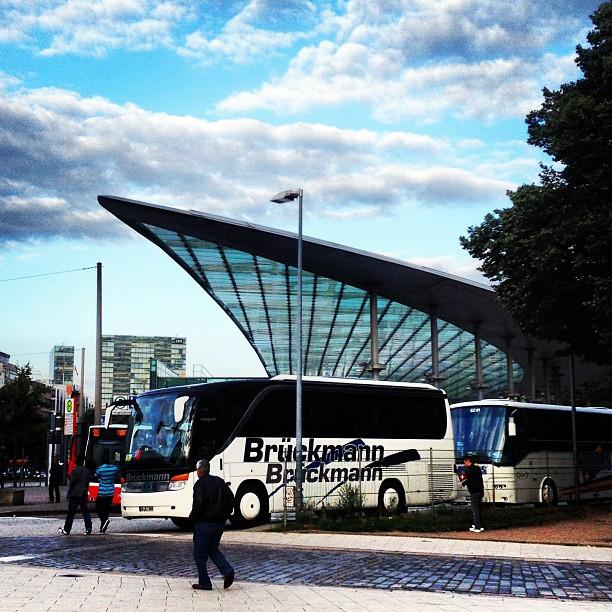What style of architecture is the triangular glass building in the background?
Quick response, please. Modern. What type of vehicles are these?
Write a very short answer. Buses. Is this a German tour bus?
Concise answer only. Yes. 